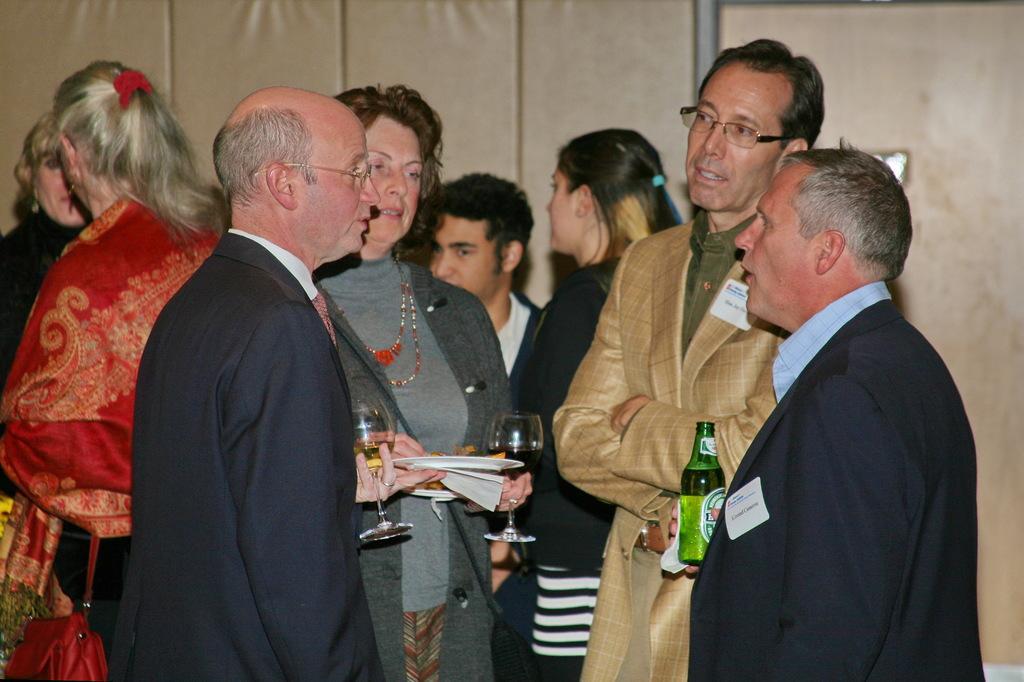In one or two sentences, can you explain what this image depicts? There are groups of people standing and talking to each other. Among them few people are holding wine glasses, plates and bottle in their hands. This looks like a wall. 